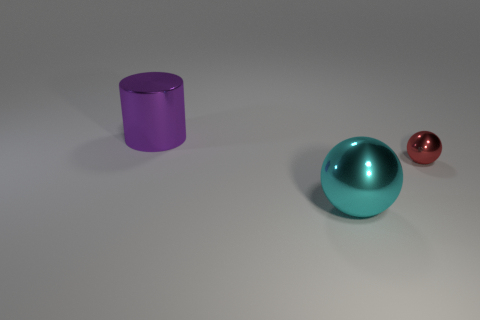Add 1 small red shiny objects. How many objects exist? 4 Subtract all spheres. How many objects are left? 1 Subtract all tiny red metallic balls. Subtract all tiny red balls. How many objects are left? 1 Add 1 big purple objects. How many big purple objects are left? 2 Add 2 tiny red spheres. How many tiny red spheres exist? 3 Subtract 1 cyan balls. How many objects are left? 2 